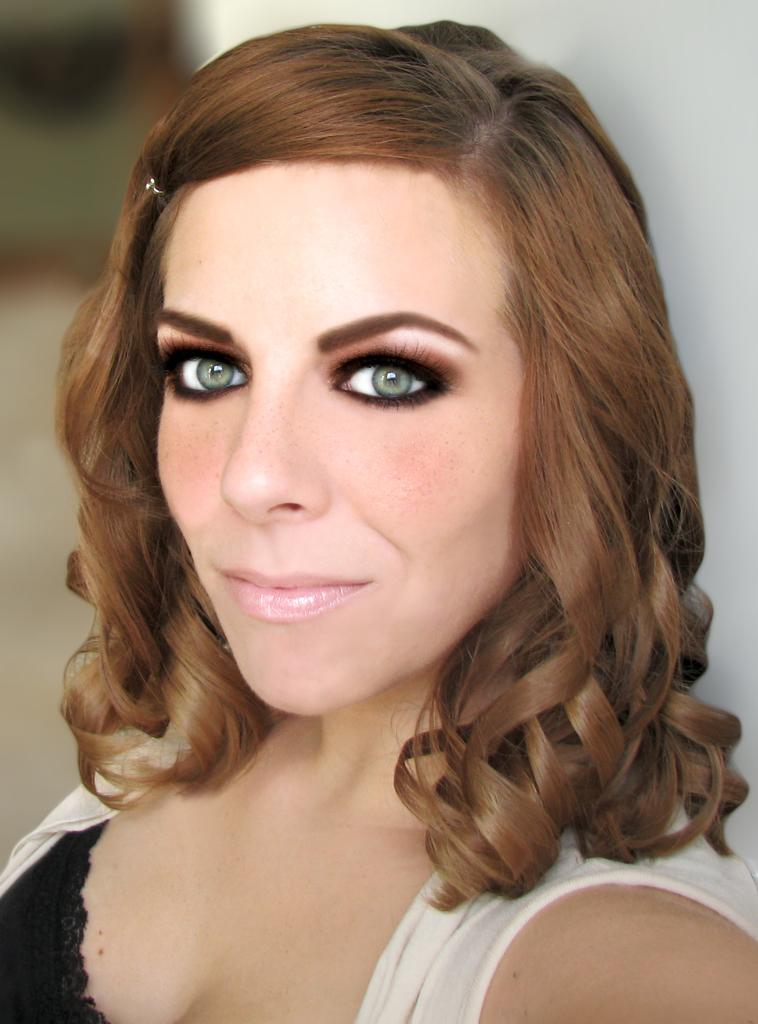What is the main subject of the image? The main subject of the image is a woman. What is the woman wearing in the image? The woman is wearing a white jacket. What expression does the woman have in the image? The woman is smiling. What can be seen in the background of the image? There is a white wall in the background of the image. What type of brush is the woman using to paint the baby in the image? There is no brush or baby present in the image; it features a woman wearing a white jacket and smiling. 